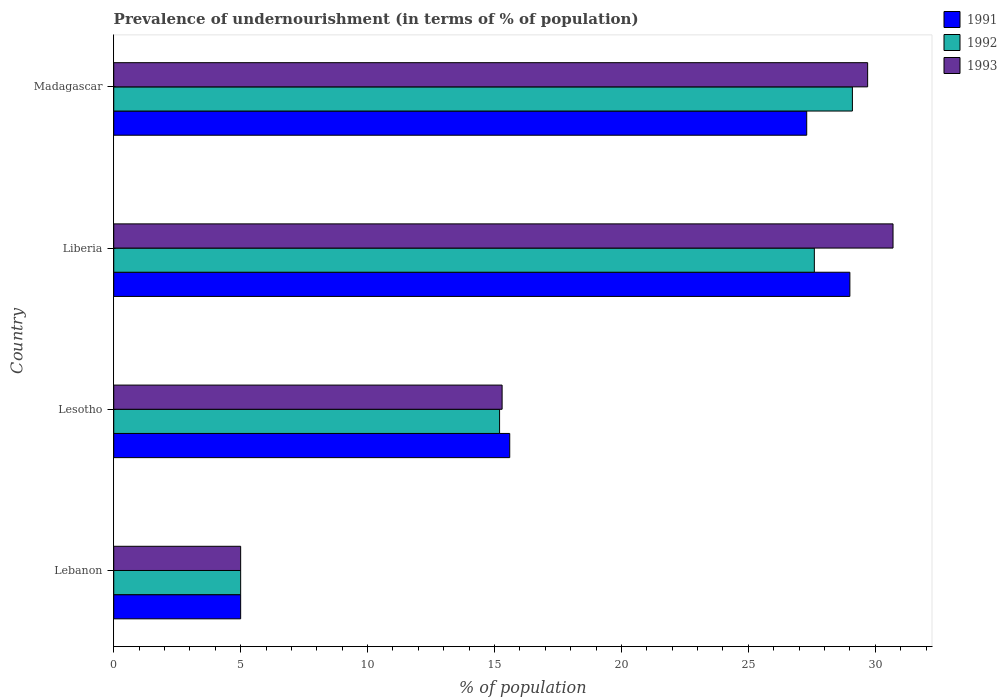How many bars are there on the 1st tick from the bottom?
Provide a short and direct response. 3. What is the label of the 4th group of bars from the top?
Keep it short and to the point. Lebanon. What is the percentage of undernourished population in 1991 in Lebanon?
Give a very brief answer. 5. Across all countries, what is the maximum percentage of undernourished population in 1991?
Give a very brief answer. 29. Across all countries, what is the minimum percentage of undernourished population in 1991?
Provide a short and direct response. 5. In which country was the percentage of undernourished population in 1993 maximum?
Your answer should be very brief. Liberia. In which country was the percentage of undernourished population in 1991 minimum?
Offer a very short reply. Lebanon. What is the total percentage of undernourished population in 1991 in the graph?
Your answer should be very brief. 76.9. What is the difference between the percentage of undernourished population in 1993 in Lebanon and that in Liberia?
Offer a very short reply. -25.7. What is the average percentage of undernourished population in 1993 per country?
Your answer should be very brief. 20.18. What is the difference between the percentage of undernourished population in 1993 and percentage of undernourished population in 1992 in Lebanon?
Your response must be concise. 0. What is the ratio of the percentage of undernourished population in 1992 in Lebanon to that in Liberia?
Keep it short and to the point. 0.18. Is the percentage of undernourished population in 1992 in Liberia less than that in Madagascar?
Your answer should be very brief. Yes. Is the difference between the percentage of undernourished population in 1993 in Lebanon and Lesotho greater than the difference between the percentage of undernourished population in 1992 in Lebanon and Lesotho?
Offer a very short reply. No. What is the difference between the highest and the second highest percentage of undernourished population in 1991?
Give a very brief answer. 1.7. What is the difference between the highest and the lowest percentage of undernourished population in 1993?
Keep it short and to the point. 25.7. What does the 3rd bar from the top in Lesotho represents?
Your response must be concise. 1991. What does the 1st bar from the bottom in Liberia represents?
Keep it short and to the point. 1991. How are the legend labels stacked?
Keep it short and to the point. Vertical. What is the title of the graph?
Your response must be concise. Prevalence of undernourishment (in terms of % of population). What is the label or title of the X-axis?
Make the answer very short. % of population. What is the % of population of 1991 in Lebanon?
Ensure brevity in your answer.  5. What is the % of population of 1992 in Lesotho?
Make the answer very short. 15.2. What is the % of population of 1992 in Liberia?
Your answer should be very brief. 27.6. What is the % of population of 1993 in Liberia?
Offer a very short reply. 30.7. What is the % of population of 1991 in Madagascar?
Give a very brief answer. 27.3. What is the % of population in 1992 in Madagascar?
Offer a very short reply. 29.1. What is the % of population of 1993 in Madagascar?
Provide a short and direct response. 29.7. Across all countries, what is the maximum % of population in 1992?
Give a very brief answer. 29.1. Across all countries, what is the maximum % of population of 1993?
Offer a terse response. 30.7. What is the total % of population of 1991 in the graph?
Give a very brief answer. 76.9. What is the total % of population of 1992 in the graph?
Make the answer very short. 76.9. What is the total % of population of 1993 in the graph?
Provide a succinct answer. 80.7. What is the difference between the % of population in 1992 in Lebanon and that in Lesotho?
Provide a short and direct response. -10.2. What is the difference between the % of population of 1992 in Lebanon and that in Liberia?
Ensure brevity in your answer.  -22.6. What is the difference between the % of population of 1993 in Lebanon and that in Liberia?
Offer a terse response. -25.7. What is the difference between the % of population in 1991 in Lebanon and that in Madagascar?
Give a very brief answer. -22.3. What is the difference between the % of population of 1992 in Lebanon and that in Madagascar?
Keep it short and to the point. -24.1. What is the difference between the % of population of 1993 in Lebanon and that in Madagascar?
Give a very brief answer. -24.7. What is the difference between the % of population of 1991 in Lesotho and that in Liberia?
Keep it short and to the point. -13.4. What is the difference between the % of population in 1992 in Lesotho and that in Liberia?
Provide a short and direct response. -12.4. What is the difference between the % of population in 1993 in Lesotho and that in Liberia?
Make the answer very short. -15.4. What is the difference between the % of population in 1992 in Lesotho and that in Madagascar?
Your response must be concise. -13.9. What is the difference between the % of population of 1993 in Lesotho and that in Madagascar?
Keep it short and to the point. -14.4. What is the difference between the % of population of 1991 in Lebanon and the % of population of 1992 in Lesotho?
Offer a very short reply. -10.2. What is the difference between the % of population of 1991 in Lebanon and the % of population of 1993 in Lesotho?
Ensure brevity in your answer.  -10.3. What is the difference between the % of population of 1992 in Lebanon and the % of population of 1993 in Lesotho?
Your response must be concise. -10.3. What is the difference between the % of population in 1991 in Lebanon and the % of population in 1992 in Liberia?
Provide a short and direct response. -22.6. What is the difference between the % of population of 1991 in Lebanon and the % of population of 1993 in Liberia?
Your answer should be very brief. -25.7. What is the difference between the % of population in 1992 in Lebanon and the % of population in 1993 in Liberia?
Offer a terse response. -25.7. What is the difference between the % of population in 1991 in Lebanon and the % of population in 1992 in Madagascar?
Ensure brevity in your answer.  -24.1. What is the difference between the % of population in 1991 in Lebanon and the % of population in 1993 in Madagascar?
Keep it short and to the point. -24.7. What is the difference between the % of population of 1992 in Lebanon and the % of population of 1993 in Madagascar?
Make the answer very short. -24.7. What is the difference between the % of population in 1991 in Lesotho and the % of population in 1993 in Liberia?
Offer a terse response. -15.1. What is the difference between the % of population in 1992 in Lesotho and the % of population in 1993 in Liberia?
Provide a short and direct response. -15.5. What is the difference between the % of population in 1991 in Lesotho and the % of population in 1992 in Madagascar?
Provide a short and direct response. -13.5. What is the difference between the % of population in 1991 in Lesotho and the % of population in 1993 in Madagascar?
Your response must be concise. -14.1. What is the difference between the % of population in 1992 in Lesotho and the % of population in 1993 in Madagascar?
Your answer should be compact. -14.5. What is the difference between the % of population of 1991 in Liberia and the % of population of 1993 in Madagascar?
Offer a terse response. -0.7. What is the average % of population of 1991 per country?
Provide a succinct answer. 19.23. What is the average % of population of 1992 per country?
Ensure brevity in your answer.  19.23. What is the average % of population in 1993 per country?
Your response must be concise. 20.18. What is the difference between the % of population of 1991 and % of population of 1992 in Lesotho?
Your answer should be very brief. 0.4. What is the difference between the % of population in 1991 and % of population in 1992 in Liberia?
Your answer should be compact. 1.4. What is the difference between the % of population in 1992 and % of population in 1993 in Liberia?
Ensure brevity in your answer.  -3.1. What is the difference between the % of population in 1991 and % of population in 1993 in Madagascar?
Your answer should be compact. -2.4. What is the difference between the % of population in 1992 and % of population in 1993 in Madagascar?
Offer a terse response. -0.6. What is the ratio of the % of population of 1991 in Lebanon to that in Lesotho?
Your answer should be compact. 0.32. What is the ratio of the % of population of 1992 in Lebanon to that in Lesotho?
Keep it short and to the point. 0.33. What is the ratio of the % of population in 1993 in Lebanon to that in Lesotho?
Provide a short and direct response. 0.33. What is the ratio of the % of population in 1991 in Lebanon to that in Liberia?
Provide a short and direct response. 0.17. What is the ratio of the % of population of 1992 in Lebanon to that in Liberia?
Your answer should be compact. 0.18. What is the ratio of the % of population of 1993 in Lebanon to that in Liberia?
Make the answer very short. 0.16. What is the ratio of the % of population in 1991 in Lebanon to that in Madagascar?
Give a very brief answer. 0.18. What is the ratio of the % of population in 1992 in Lebanon to that in Madagascar?
Keep it short and to the point. 0.17. What is the ratio of the % of population of 1993 in Lebanon to that in Madagascar?
Keep it short and to the point. 0.17. What is the ratio of the % of population in 1991 in Lesotho to that in Liberia?
Your response must be concise. 0.54. What is the ratio of the % of population in 1992 in Lesotho to that in Liberia?
Ensure brevity in your answer.  0.55. What is the ratio of the % of population in 1993 in Lesotho to that in Liberia?
Your response must be concise. 0.5. What is the ratio of the % of population of 1991 in Lesotho to that in Madagascar?
Offer a terse response. 0.57. What is the ratio of the % of population in 1992 in Lesotho to that in Madagascar?
Make the answer very short. 0.52. What is the ratio of the % of population of 1993 in Lesotho to that in Madagascar?
Your response must be concise. 0.52. What is the ratio of the % of population in 1991 in Liberia to that in Madagascar?
Give a very brief answer. 1.06. What is the ratio of the % of population of 1992 in Liberia to that in Madagascar?
Your answer should be compact. 0.95. What is the ratio of the % of population in 1993 in Liberia to that in Madagascar?
Provide a succinct answer. 1.03. What is the difference between the highest and the lowest % of population in 1992?
Your response must be concise. 24.1. What is the difference between the highest and the lowest % of population in 1993?
Make the answer very short. 25.7. 